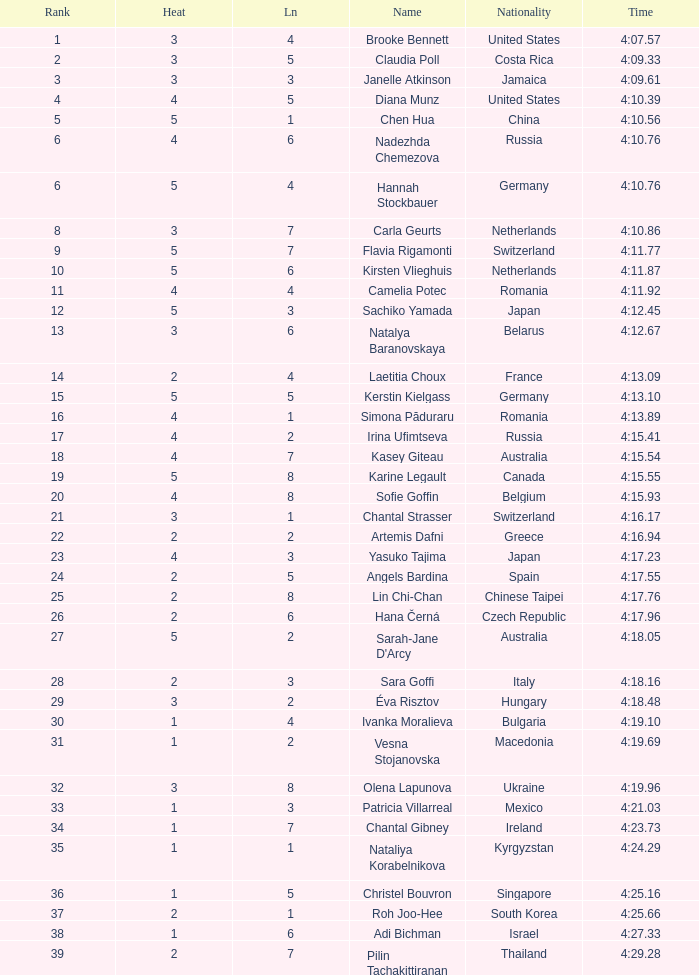Name the total number of lane for brooke bennett and rank less than 1 0.0. 